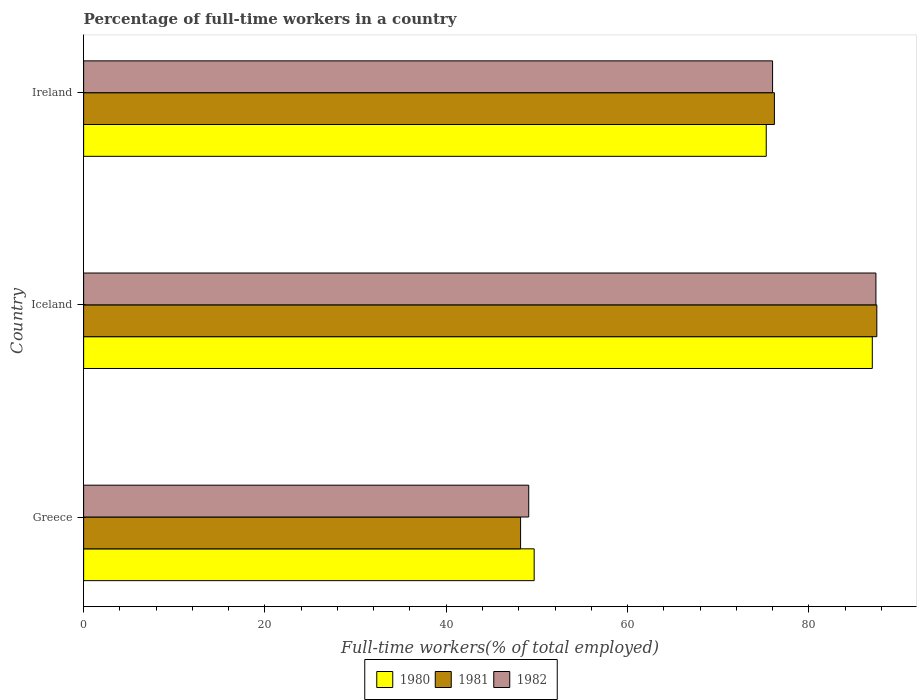How many different coloured bars are there?
Ensure brevity in your answer.  3. How many bars are there on the 2nd tick from the top?
Provide a short and direct response. 3. What is the label of the 2nd group of bars from the top?
Ensure brevity in your answer.  Iceland. In how many cases, is the number of bars for a given country not equal to the number of legend labels?
Make the answer very short. 0. What is the percentage of full-time workers in 1982 in Ireland?
Provide a short and direct response. 76. Across all countries, what is the maximum percentage of full-time workers in 1982?
Your response must be concise. 87.4. Across all countries, what is the minimum percentage of full-time workers in 1982?
Provide a short and direct response. 49.1. In which country was the percentage of full-time workers in 1982 minimum?
Your answer should be very brief. Greece. What is the total percentage of full-time workers in 1982 in the graph?
Your response must be concise. 212.5. What is the difference between the percentage of full-time workers in 1981 in Greece and that in Iceland?
Ensure brevity in your answer.  -39.3. What is the difference between the percentage of full-time workers in 1982 in Greece and the percentage of full-time workers in 1981 in Iceland?
Your response must be concise. -38.4. What is the average percentage of full-time workers in 1980 per country?
Your answer should be very brief. 70.67. In how many countries, is the percentage of full-time workers in 1981 greater than 36 %?
Your answer should be very brief. 3. What is the ratio of the percentage of full-time workers in 1982 in Iceland to that in Ireland?
Ensure brevity in your answer.  1.15. What is the difference between the highest and the second highest percentage of full-time workers in 1982?
Make the answer very short. 11.4. What is the difference between the highest and the lowest percentage of full-time workers in 1982?
Make the answer very short. 38.3. Is the sum of the percentage of full-time workers in 1981 in Iceland and Ireland greater than the maximum percentage of full-time workers in 1982 across all countries?
Offer a very short reply. Yes. Where does the legend appear in the graph?
Your response must be concise. Bottom center. How are the legend labels stacked?
Your response must be concise. Horizontal. What is the title of the graph?
Provide a short and direct response. Percentage of full-time workers in a country. What is the label or title of the X-axis?
Ensure brevity in your answer.  Full-time workers(% of total employed). What is the label or title of the Y-axis?
Your answer should be very brief. Country. What is the Full-time workers(% of total employed) in 1980 in Greece?
Your answer should be compact. 49.7. What is the Full-time workers(% of total employed) of 1981 in Greece?
Give a very brief answer. 48.2. What is the Full-time workers(% of total employed) of 1982 in Greece?
Offer a terse response. 49.1. What is the Full-time workers(% of total employed) of 1980 in Iceland?
Keep it short and to the point. 87. What is the Full-time workers(% of total employed) in 1981 in Iceland?
Ensure brevity in your answer.  87.5. What is the Full-time workers(% of total employed) of 1982 in Iceland?
Offer a very short reply. 87.4. What is the Full-time workers(% of total employed) of 1980 in Ireland?
Keep it short and to the point. 75.3. What is the Full-time workers(% of total employed) in 1981 in Ireland?
Provide a succinct answer. 76.2. Across all countries, what is the maximum Full-time workers(% of total employed) of 1980?
Your answer should be very brief. 87. Across all countries, what is the maximum Full-time workers(% of total employed) in 1981?
Offer a very short reply. 87.5. Across all countries, what is the maximum Full-time workers(% of total employed) of 1982?
Provide a succinct answer. 87.4. Across all countries, what is the minimum Full-time workers(% of total employed) of 1980?
Your response must be concise. 49.7. Across all countries, what is the minimum Full-time workers(% of total employed) in 1981?
Provide a short and direct response. 48.2. Across all countries, what is the minimum Full-time workers(% of total employed) of 1982?
Your answer should be very brief. 49.1. What is the total Full-time workers(% of total employed) in 1980 in the graph?
Your response must be concise. 212. What is the total Full-time workers(% of total employed) in 1981 in the graph?
Offer a very short reply. 211.9. What is the total Full-time workers(% of total employed) of 1982 in the graph?
Your answer should be very brief. 212.5. What is the difference between the Full-time workers(% of total employed) of 1980 in Greece and that in Iceland?
Your answer should be compact. -37.3. What is the difference between the Full-time workers(% of total employed) of 1981 in Greece and that in Iceland?
Your response must be concise. -39.3. What is the difference between the Full-time workers(% of total employed) of 1982 in Greece and that in Iceland?
Your answer should be compact. -38.3. What is the difference between the Full-time workers(% of total employed) in 1980 in Greece and that in Ireland?
Keep it short and to the point. -25.6. What is the difference between the Full-time workers(% of total employed) in 1982 in Greece and that in Ireland?
Give a very brief answer. -26.9. What is the difference between the Full-time workers(% of total employed) of 1980 in Iceland and that in Ireland?
Provide a short and direct response. 11.7. What is the difference between the Full-time workers(% of total employed) in 1981 in Iceland and that in Ireland?
Provide a short and direct response. 11.3. What is the difference between the Full-time workers(% of total employed) in 1982 in Iceland and that in Ireland?
Provide a short and direct response. 11.4. What is the difference between the Full-time workers(% of total employed) in 1980 in Greece and the Full-time workers(% of total employed) in 1981 in Iceland?
Provide a short and direct response. -37.8. What is the difference between the Full-time workers(% of total employed) of 1980 in Greece and the Full-time workers(% of total employed) of 1982 in Iceland?
Provide a succinct answer. -37.7. What is the difference between the Full-time workers(% of total employed) in 1981 in Greece and the Full-time workers(% of total employed) in 1982 in Iceland?
Provide a short and direct response. -39.2. What is the difference between the Full-time workers(% of total employed) of 1980 in Greece and the Full-time workers(% of total employed) of 1981 in Ireland?
Ensure brevity in your answer.  -26.5. What is the difference between the Full-time workers(% of total employed) in 1980 in Greece and the Full-time workers(% of total employed) in 1982 in Ireland?
Provide a succinct answer. -26.3. What is the difference between the Full-time workers(% of total employed) in 1981 in Greece and the Full-time workers(% of total employed) in 1982 in Ireland?
Keep it short and to the point. -27.8. What is the difference between the Full-time workers(% of total employed) of 1981 in Iceland and the Full-time workers(% of total employed) of 1982 in Ireland?
Your answer should be compact. 11.5. What is the average Full-time workers(% of total employed) of 1980 per country?
Ensure brevity in your answer.  70.67. What is the average Full-time workers(% of total employed) of 1981 per country?
Keep it short and to the point. 70.63. What is the average Full-time workers(% of total employed) of 1982 per country?
Your answer should be very brief. 70.83. What is the difference between the Full-time workers(% of total employed) of 1980 and Full-time workers(% of total employed) of 1981 in Iceland?
Your answer should be very brief. -0.5. What is the difference between the Full-time workers(% of total employed) of 1980 and Full-time workers(% of total employed) of 1982 in Iceland?
Your answer should be very brief. -0.4. What is the difference between the Full-time workers(% of total employed) of 1980 and Full-time workers(% of total employed) of 1982 in Ireland?
Give a very brief answer. -0.7. What is the difference between the Full-time workers(% of total employed) in 1981 and Full-time workers(% of total employed) in 1982 in Ireland?
Ensure brevity in your answer.  0.2. What is the ratio of the Full-time workers(% of total employed) of 1980 in Greece to that in Iceland?
Ensure brevity in your answer.  0.57. What is the ratio of the Full-time workers(% of total employed) in 1981 in Greece to that in Iceland?
Keep it short and to the point. 0.55. What is the ratio of the Full-time workers(% of total employed) in 1982 in Greece to that in Iceland?
Your response must be concise. 0.56. What is the ratio of the Full-time workers(% of total employed) in 1980 in Greece to that in Ireland?
Your answer should be very brief. 0.66. What is the ratio of the Full-time workers(% of total employed) in 1981 in Greece to that in Ireland?
Make the answer very short. 0.63. What is the ratio of the Full-time workers(% of total employed) of 1982 in Greece to that in Ireland?
Offer a very short reply. 0.65. What is the ratio of the Full-time workers(% of total employed) of 1980 in Iceland to that in Ireland?
Your answer should be very brief. 1.16. What is the ratio of the Full-time workers(% of total employed) in 1981 in Iceland to that in Ireland?
Give a very brief answer. 1.15. What is the ratio of the Full-time workers(% of total employed) in 1982 in Iceland to that in Ireland?
Your answer should be very brief. 1.15. What is the difference between the highest and the second highest Full-time workers(% of total employed) of 1982?
Provide a short and direct response. 11.4. What is the difference between the highest and the lowest Full-time workers(% of total employed) in 1980?
Your answer should be very brief. 37.3. What is the difference between the highest and the lowest Full-time workers(% of total employed) of 1981?
Ensure brevity in your answer.  39.3. What is the difference between the highest and the lowest Full-time workers(% of total employed) in 1982?
Provide a succinct answer. 38.3. 